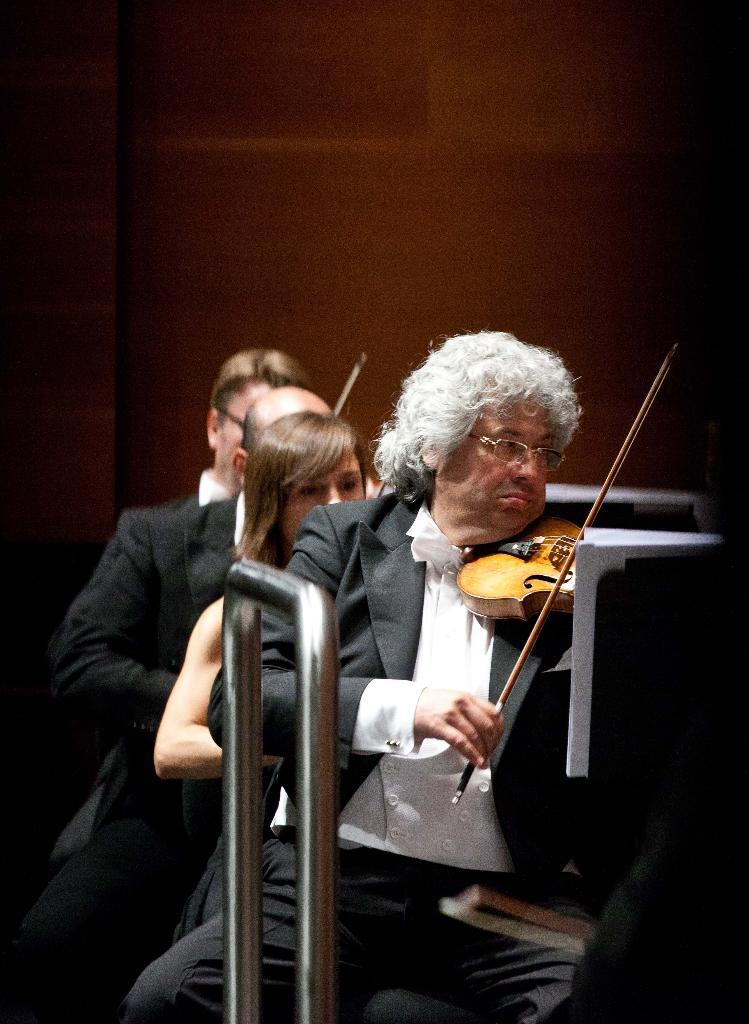How many people are playing violins in the image? There are four persons in the image, and they are playing violins. Can you describe the arrangement of the persons in the image? There is a woman in the middle of the image, and the other three persons are positioned around her. What is visible in the background of the image? There is a wall in the background of the image. What is placed in front of the persons? There is a paper in front of the persons. What type of popcorn is being served to the pig in the image? There is no popcorn or pig present in the image; it features four persons playing violins with a paper in front of them. How does the behavior of the persons playing violins change throughout the image? The image is a still photograph, so the behavior of the persons playing violins does not change throughout the image. 